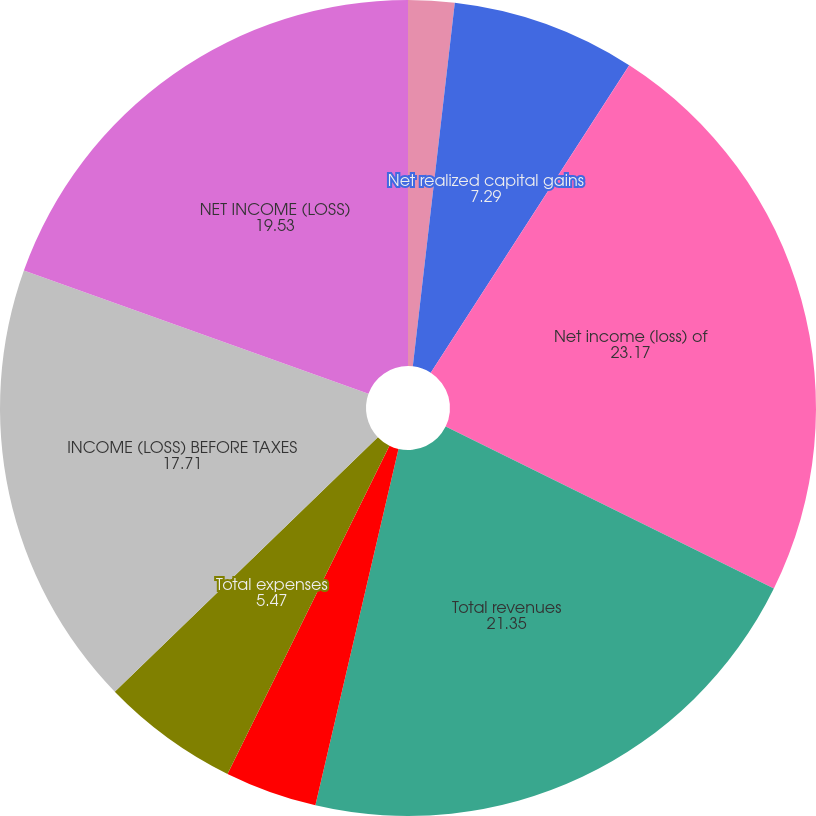Convert chart to OTSL. <chart><loc_0><loc_0><loc_500><loc_500><pie_chart><fcel>Net investment income<fcel>Net realized capital gains<fcel>Other income (expense)<fcel>Net income (loss) of<fcel>Total revenues<fcel>Other expenses<fcel>Total expenses<fcel>INCOME (LOSS) BEFORE TAXES<fcel>NET INCOME (LOSS)<nl><fcel>1.83%<fcel>7.29%<fcel>0.01%<fcel>23.17%<fcel>21.35%<fcel>3.65%<fcel>5.47%<fcel>17.71%<fcel>19.53%<nl></chart> 